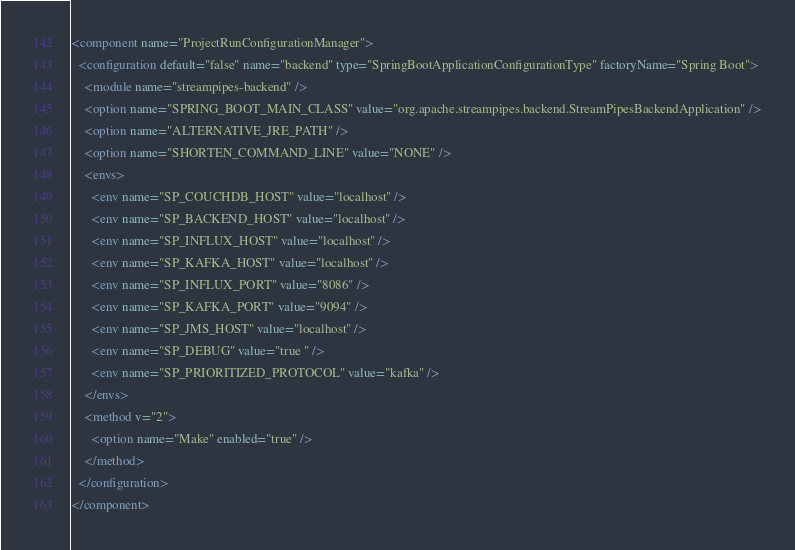<code> <loc_0><loc_0><loc_500><loc_500><_XML_><component name="ProjectRunConfigurationManager">
  <configuration default="false" name="backend" type="SpringBootApplicationConfigurationType" factoryName="Spring Boot">
    <module name="streampipes-backend" />
    <option name="SPRING_BOOT_MAIN_CLASS" value="org.apache.streampipes.backend.StreamPipesBackendApplication" />
    <option name="ALTERNATIVE_JRE_PATH" />
    <option name="SHORTEN_COMMAND_LINE" value="NONE" />
    <envs>
      <env name="SP_COUCHDB_HOST" value="localhost" />
      <env name="SP_BACKEND_HOST" value="localhost" />
      <env name="SP_INFLUX_HOST" value="localhost" />
      <env name="SP_KAFKA_HOST" value="localhost" />
      <env name="SP_INFLUX_PORT" value="8086" />
      <env name="SP_KAFKA_PORT" value="9094" />
      <env name="SP_JMS_HOST" value="localhost" />
      <env name="SP_DEBUG" value="true " />
      <env name="SP_PRIORITIZED_PROTOCOL" value="kafka" />
    </envs>
    <method v="2">
      <option name="Make" enabled="true" />
    </method>
  </configuration>
</component></code> 